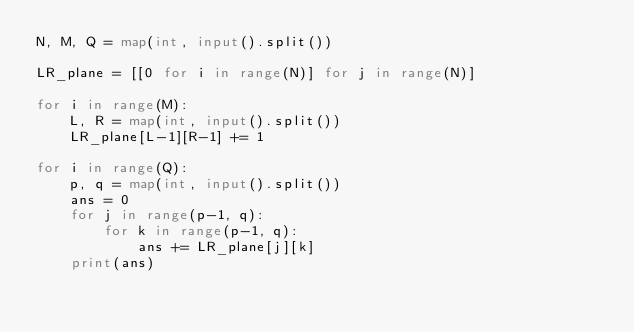Convert code to text. <code><loc_0><loc_0><loc_500><loc_500><_Python_>N, M, Q = map(int, input().split())

LR_plane = [[0 for i in range(N)] for j in range(N)]

for i in range(M):
    L, R = map(int, input().split())
    LR_plane[L-1][R-1] += 1

for i in range(Q):
    p, q = map(int, input().split())
    ans = 0
    for j in range(p-1, q):
        for k in range(p-1, q):
            ans += LR_plane[j][k]
    print(ans)
</code> 